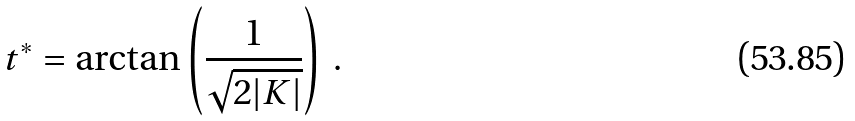Convert formula to latex. <formula><loc_0><loc_0><loc_500><loc_500>t ^ { * } = \arctan \left ( \frac { 1 } { \sqrt { 2 | K | } } \right ) \, .</formula> 